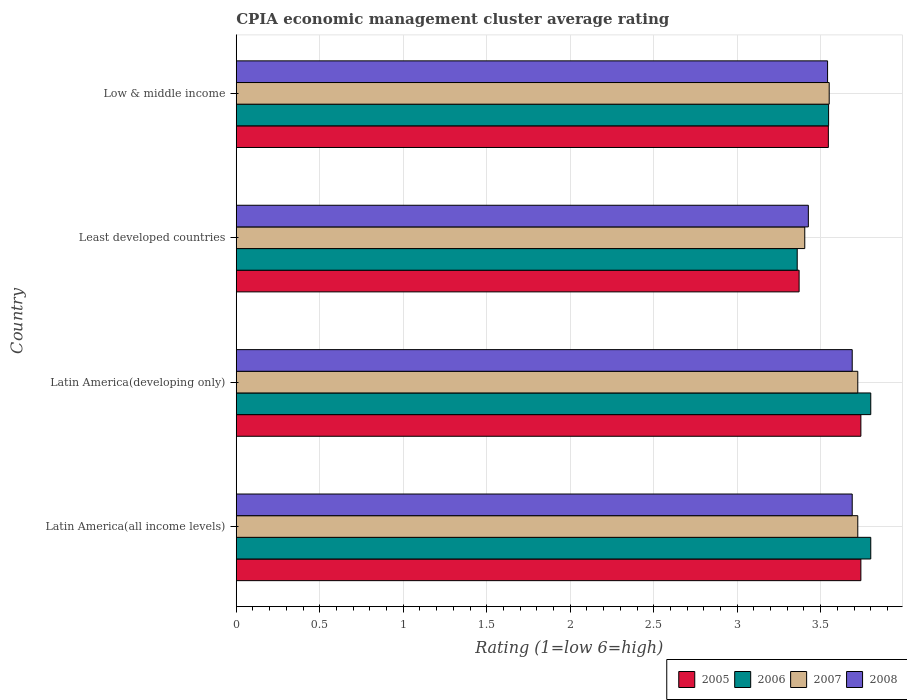How many different coloured bars are there?
Keep it short and to the point. 4. Are the number of bars per tick equal to the number of legend labels?
Offer a very short reply. Yes. What is the CPIA rating in 2008 in Latin America(all income levels)?
Ensure brevity in your answer.  3.69. Across all countries, what is the maximum CPIA rating in 2006?
Offer a very short reply. 3.8. Across all countries, what is the minimum CPIA rating in 2007?
Offer a very short reply. 3.4. In which country was the CPIA rating in 2007 maximum?
Your answer should be very brief. Latin America(all income levels). In which country was the CPIA rating in 2005 minimum?
Ensure brevity in your answer.  Least developed countries. What is the total CPIA rating in 2006 in the graph?
Make the answer very short. 14.51. What is the difference between the CPIA rating in 2008 in Latin America(developing only) and that in Least developed countries?
Your response must be concise. 0.26. What is the difference between the CPIA rating in 2006 in Latin America(all income levels) and the CPIA rating in 2005 in Least developed countries?
Make the answer very short. 0.43. What is the average CPIA rating in 2007 per country?
Ensure brevity in your answer.  3.6. What is the difference between the CPIA rating in 2005 and CPIA rating in 2007 in Latin America(developing only)?
Provide a short and direct response. 0.02. In how many countries, is the CPIA rating in 2006 greater than 0.8 ?
Give a very brief answer. 4. What is the ratio of the CPIA rating in 2007 in Least developed countries to that in Low & middle income?
Your answer should be very brief. 0.96. Is the CPIA rating in 2005 in Latin America(developing only) less than that in Low & middle income?
Your response must be concise. No. Is the difference between the CPIA rating in 2005 in Latin America(all income levels) and Latin America(developing only) greater than the difference between the CPIA rating in 2007 in Latin America(all income levels) and Latin America(developing only)?
Give a very brief answer. No. What is the difference between the highest and the second highest CPIA rating in 2005?
Make the answer very short. 0. What is the difference between the highest and the lowest CPIA rating in 2007?
Offer a very short reply. 0.32. Is it the case that in every country, the sum of the CPIA rating in 2008 and CPIA rating in 2006 is greater than the sum of CPIA rating in 2007 and CPIA rating in 2005?
Give a very brief answer. No. What does the 2nd bar from the top in Latin America(all income levels) represents?
Your response must be concise. 2007. Are all the bars in the graph horizontal?
Offer a terse response. Yes. Does the graph contain any zero values?
Give a very brief answer. No. Does the graph contain grids?
Provide a succinct answer. Yes. How many legend labels are there?
Offer a terse response. 4. How are the legend labels stacked?
Offer a very short reply. Horizontal. What is the title of the graph?
Ensure brevity in your answer.  CPIA economic management cluster average rating. What is the label or title of the X-axis?
Keep it short and to the point. Rating (1=low 6=high). What is the label or title of the Y-axis?
Keep it short and to the point. Country. What is the Rating (1=low 6=high) of 2005 in Latin America(all income levels)?
Provide a short and direct response. 3.74. What is the Rating (1=low 6=high) of 2006 in Latin America(all income levels)?
Give a very brief answer. 3.8. What is the Rating (1=low 6=high) of 2007 in Latin America(all income levels)?
Offer a very short reply. 3.72. What is the Rating (1=low 6=high) of 2008 in Latin America(all income levels)?
Offer a terse response. 3.69. What is the Rating (1=low 6=high) in 2005 in Latin America(developing only)?
Your answer should be compact. 3.74. What is the Rating (1=low 6=high) in 2007 in Latin America(developing only)?
Your answer should be compact. 3.72. What is the Rating (1=low 6=high) of 2008 in Latin America(developing only)?
Give a very brief answer. 3.69. What is the Rating (1=low 6=high) of 2005 in Least developed countries?
Give a very brief answer. 3.37. What is the Rating (1=low 6=high) in 2006 in Least developed countries?
Your answer should be very brief. 3.36. What is the Rating (1=low 6=high) in 2007 in Least developed countries?
Your answer should be compact. 3.4. What is the Rating (1=low 6=high) in 2008 in Least developed countries?
Provide a succinct answer. 3.43. What is the Rating (1=low 6=high) in 2005 in Low & middle income?
Your answer should be very brief. 3.55. What is the Rating (1=low 6=high) in 2006 in Low & middle income?
Offer a very short reply. 3.55. What is the Rating (1=low 6=high) of 2007 in Low & middle income?
Your answer should be compact. 3.55. What is the Rating (1=low 6=high) in 2008 in Low & middle income?
Your answer should be compact. 3.54. Across all countries, what is the maximum Rating (1=low 6=high) in 2005?
Make the answer very short. 3.74. Across all countries, what is the maximum Rating (1=low 6=high) in 2006?
Your answer should be very brief. 3.8. Across all countries, what is the maximum Rating (1=low 6=high) of 2007?
Your answer should be very brief. 3.72. Across all countries, what is the maximum Rating (1=low 6=high) of 2008?
Your response must be concise. 3.69. Across all countries, what is the minimum Rating (1=low 6=high) in 2005?
Your answer should be compact. 3.37. Across all countries, what is the minimum Rating (1=low 6=high) of 2006?
Make the answer very short. 3.36. Across all countries, what is the minimum Rating (1=low 6=high) in 2007?
Your answer should be compact. 3.4. Across all countries, what is the minimum Rating (1=low 6=high) of 2008?
Give a very brief answer. 3.43. What is the total Rating (1=low 6=high) of 2005 in the graph?
Ensure brevity in your answer.  14.4. What is the total Rating (1=low 6=high) in 2006 in the graph?
Ensure brevity in your answer.  14.51. What is the total Rating (1=low 6=high) of 2007 in the graph?
Your response must be concise. 14.4. What is the total Rating (1=low 6=high) of 2008 in the graph?
Your answer should be compact. 14.35. What is the difference between the Rating (1=low 6=high) in 2006 in Latin America(all income levels) and that in Latin America(developing only)?
Your response must be concise. 0. What is the difference between the Rating (1=low 6=high) of 2005 in Latin America(all income levels) and that in Least developed countries?
Ensure brevity in your answer.  0.37. What is the difference between the Rating (1=low 6=high) in 2006 in Latin America(all income levels) and that in Least developed countries?
Provide a short and direct response. 0.44. What is the difference between the Rating (1=low 6=high) of 2007 in Latin America(all income levels) and that in Least developed countries?
Your answer should be compact. 0.32. What is the difference between the Rating (1=low 6=high) of 2008 in Latin America(all income levels) and that in Least developed countries?
Make the answer very short. 0.26. What is the difference between the Rating (1=low 6=high) of 2005 in Latin America(all income levels) and that in Low & middle income?
Provide a succinct answer. 0.19. What is the difference between the Rating (1=low 6=high) in 2006 in Latin America(all income levels) and that in Low & middle income?
Give a very brief answer. 0.25. What is the difference between the Rating (1=low 6=high) of 2007 in Latin America(all income levels) and that in Low & middle income?
Ensure brevity in your answer.  0.17. What is the difference between the Rating (1=low 6=high) in 2008 in Latin America(all income levels) and that in Low & middle income?
Provide a short and direct response. 0.15. What is the difference between the Rating (1=low 6=high) of 2005 in Latin America(developing only) and that in Least developed countries?
Offer a very short reply. 0.37. What is the difference between the Rating (1=low 6=high) in 2006 in Latin America(developing only) and that in Least developed countries?
Make the answer very short. 0.44. What is the difference between the Rating (1=low 6=high) in 2007 in Latin America(developing only) and that in Least developed countries?
Offer a terse response. 0.32. What is the difference between the Rating (1=low 6=high) in 2008 in Latin America(developing only) and that in Least developed countries?
Your response must be concise. 0.26. What is the difference between the Rating (1=low 6=high) of 2005 in Latin America(developing only) and that in Low & middle income?
Offer a terse response. 0.19. What is the difference between the Rating (1=low 6=high) in 2006 in Latin America(developing only) and that in Low & middle income?
Ensure brevity in your answer.  0.25. What is the difference between the Rating (1=low 6=high) of 2007 in Latin America(developing only) and that in Low & middle income?
Your answer should be compact. 0.17. What is the difference between the Rating (1=low 6=high) of 2008 in Latin America(developing only) and that in Low & middle income?
Your answer should be compact. 0.15. What is the difference between the Rating (1=low 6=high) of 2005 in Least developed countries and that in Low & middle income?
Offer a terse response. -0.18. What is the difference between the Rating (1=low 6=high) in 2006 in Least developed countries and that in Low & middle income?
Offer a terse response. -0.19. What is the difference between the Rating (1=low 6=high) in 2007 in Least developed countries and that in Low & middle income?
Your answer should be compact. -0.15. What is the difference between the Rating (1=low 6=high) in 2008 in Least developed countries and that in Low & middle income?
Offer a very short reply. -0.12. What is the difference between the Rating (1=low 6=high) in 2005 in Latin America(all income levels) and the Rating (1=low 6=high) in 2006 in Latin America(developing only)?
Your answer should be very brief. -0.06. What is the difference between the Rating (1=low 6=high) of 2005 in Latin America(all income levels) and the Rating (1=low 6=high) of 2007 in Latin America(developing only)?
Make the answer very short. 0.02. What is the difference between the Rating (1=low 6=high) in 2005 in Latin America(all income levels) and the Rating (1=low 6=high) in 2008 in Latin America(developing only)?
Offer a terse response. 0.05. What is the difference between the Rating (1=low 6=high) in 2006 in Latin America(all income levels) and the Rating (1=low 6=high) in 2007 in Latin America(developing only)?
Your response must be concise. 0.08. What is the difference between the Rating (1=low 6=high) of 2006 in Latin America(all income levels) and the Rating (1=low 6=high) of 2008 in Latin America(developing only)?
Keep it short and to the point. 0.11. What is the difference between the Rating (1=low 6=high) in 2007 in Latin America(all income levels) and the Rating (1=low 6=high) in 2008 in Latin America(developing only)?
Your answer should be compact. 0.03. What is the difference between the Rating (1=low 6=high) of 2005 in Latin America(all income levels) and the Rating (1=low 6=high) of 2006 in Least developed countries?
Provide a short and direct response. 0.38. What is the difference between the Rating (1=low 6=high) in 2005 in Latin America(all income levels) and the Rating (1=low 6=high) in 2007 in Least developed countries?
Your response must be concise. 0.34. What is the difference between the Rating (1=low 6=high) in 2005 in Latin America(all income levels) and the Rating (1=low 6=high) in 2008 in Least developed countries?
Your answer should be very brief. 0.31. What is the difference between the Rating (1=low 6=high) in 2006 in Latin America(all income levels) and the Rating (1=low 6=high) in 2007 in Least developed countries?
Provide a short and direct response. 0.4. What is the difference between the Rating (1=low 6=high) in 2006 in Latin America(all income levels) and the Rating (1=low 6=high) in 2008 in Least developed countries?
Make the answer very short. 0.37. What is the difference between the Rating (1=low 6=high) of 2007 in Latin America(all income levels) and the Rating (1=low 6=high) of 2008 in Least developed countries?
Offer a very short reply. 0.3. What is the difference between the Rating (1=low 6=high) of 2005 in Latin America(all income levels) and the Rating (1=low 6=high) of 2006 in Low & middle income?
Ensure brevity in your answer.  0.19. What is the difference between the Rating (1=low 6=high) of 2005 in Latin America(all income levels) and the Rating (1=low 6=high) of 2007 in Low & middle income?
Provide a succinct answer. 0.19. What is the difference between the Rating (1=low 6=high) of 2005 in Latin America(all income levels) and the Rating (1=low 6=high) of 2008 in Low & middle income?
Keep it short and to the point. 0.2. What is the difference between the Rating (1=low 6=high) in 2006 in Latin America(all income levels) and the Rating (1=low 6=high) in 2007 in Low & middle income?
Your answer should be very brief. 0.25. What is the difference between the Rating (1=low 6=high) of 2006 in Latin America(all income levels) and the Rating (1=low 6=high) of 2008 in Low & middle income?
Make the answer very short. 0.26. What is the difference between the Rating (1=low 6=high) of 2007 in Latin America(all income levels) and the Rating (1=low 6=high) of 2008 in Low & middle income?
Your response must be concise. 0.18. What is the difference between the Rating (1=low 6=high) of 2005 in Latin America(developing only) and the Rating (1=low 6=high) of 2006 in Least developed countries?
Your response must be concise. 0.38. What is the difference between the Rating (1=low 6=high) in 2005 in Latin America(developing only) and the Rating (1=low 6=high) in 2007 in Least developed countries?
Provide a succinct answer. 0.34. What is the difference between the Rating (1=low 6=high) in 2005 in Latin America(developing only) and the Rating (1=low 6=high) in 2008 in Least developed countries?
Make the answer very short. 0.31. What is the difference between the Rating (1=low 6=high) of 2006 in Latin America(developing only) and the Rating (1=low 6=high) of 2007 in Least developed countries?
Your answer should be very brief. 0.4. What is the difference between the Rating (1=low 6=high) of 2006 in Latin America(developing only) and the Rating (1=low 6=high) of 2008 in Least developed countries?
Your response must be concise. 0.37. What is the difference between the Rating (1=low 6=high) in 2007 in Latin America(developing only) and the Rating (1=low 6=high) in 2008 in Least developed countries?
Keep it short and to the point. 0.3. What is the difference between the Rating (1=low 6=high) in 2005 in Latin America(developing only) and the Rating (1=low 6=high) in 2006 in Low & middle income?
Give a very brief answer. 0.19. What is the difference between the Rating (1=low 6=high) in 2005 in Latin America(developing only) and the Rating (1=low 6=high) in 2007 in Low & middle income?
Make the answer very short. 0.19. What is the difference between the Rating (1=low 6=high) in 2005 in Latin America(developing only) and the Rating (1=low 6=high) in 2008 in Low & middle income?
Your answer should be very brief. 0.2. What is the difference between the Rating (1=low 6=high) in 2006 in Latin America(developing only) and the Rating (1=low 6=high) in 2007 in Low & middle income?
Your response must be concise. 0.25. What is the difference between the Rating (1=low 6=high) in 2006 in Latin America(developing only) and the Rating (1=low 6=high) in 2008 in Low & middle income?
Keep it short and to the point. 0.26. What is the difference between the Rating (1=low 6=high) in 2007 in Latin America(developing only) and the Rating (1=low 6=high) in 2008 in Low & middle income?
Your answer should be very brief. 0.18. What is the difference between the Rating (1=low 6=high) in 2005 in Least developed countries and the Rating (1=low 6=high) in 2006 in Low & middle income?
Offer a terse response. -0.18. What is the difference between the Rating (1=low 6=high) in 2005 in Least developed countries and the Rating (1=low 6=high) in 2007 in Low & middle income?
Keep it short and to the point. -0.18. What is the difference between the Rating (1=low 6=high) of 2005 in Least developed countries and the Rating (1=low 6=high) of 2008 in Low & middle income?
Make the answer very short. -0.17. What is the difference between the Rating (1=low 6=high) of 2006 in Least developed countries and the Rating (1=low 6=high) of 2007 in Low & middle income?
Ensure brevity in your answer.  -0.19. What is the difference between the Rating (1=low 6=high) of 2006 in Least developed countries and the Rating (1=low 6=high) of 2008 in Low & middle income?
Make the answer very short. -0.18. What is the difference between the Rating (1=low 6=high) in 2007 in Least developed countries and the Rating (1=low 6=high) in 2008 in Low & middle income?
Keep it short and to the point. -0.14. What is the average Rating (1=low 6=high) in 2005 per country?
Your answer should be compact. 3.6. What is the average Rating (1=low 6=high) in 2006 per country?
Offer a terse response. 3.63. What is the average Rating (1=low 6=high) of 2007 per country?
Offer a very short reply. 3.6. What is the average Rating (1=low 6=high) of 2008 per country?
Make the answer very short. 3.59. What is the difference between the Rating (1=low 6=high) in 2005 and Rating (1=low 6=high) in 2006 in Latin America(all income levels)?
Your answer should be compact. -0.06. What is the difference between the Rating (1=low 6=high) in 2005 and Rating (1=low 6=high) in 2007 in Latin America(all income levels)?
Make the answer very short. 0.02. What is the difference between the Rating (1=low 6=high) of 2005 and Rating (1=low 6=high) of 2008 in Latin America(all income levels)?
Make the answer very short. 0.05. What is the difference between the Rating (1=low 6=high) in 2006 and Rating (1=low 6=high) in 2007 in Latin America(all income levels)?
Ensure brevity in your answer.  0.08. What is the difference between the Rating (1=low 6=high) in 2006 and Rating (1=low 6=high) in 2008 in Latin America(all income levels)?
Give a very brief answer. 0.11. What is the difference between the Rating (1=low 6=high) in 2005 and Rating (1=low 6=high) in 2006 in Latin America(developing only)?
Ensure brevity in your answer.  -0.06. What is the difference between the Rating (1=low 6=high) of 2005 and Rating (1=low 6=high) of 2007 in Latin America(developing only)?
Make the answer very short. 0.02. What is the difference between the Rating (1=low 6=high) in 2005 and Rating (1=low 6=high) in 2008 in Latin America(developing only)?
Give a very brief answer. 0.05. What is the difference between the Rating (1=low 6=high) of 2006 and Rating (1=low 6=high) of 2007 in Latin America(developing only)?
Your answer should be compact. 0.08. What is the difference between the Rating (1=low 6=high) of 2007 and Rating (1=low 6=high) of 2008 in Latin America(developing only)?
Offer a very short reply. 0.03. What is the difference between the Rating (1=low 6=high) in 2005 and Rating (1=low 6=high) in 2006 in Least developed countries?
Your response must be concise. 0.01. What is the difference between the Rating (1=low 6=high) of 2005 and Rating (1=low 6=high) of 2007 in Least developed countries?
Make the answer very short. -0.03. What is the difference between the Rating (1=low 6=high) in 2005 and Rating (1=low 6=high) in 2008 in Least developed countries?
Provide a short and direct response. -0.06. What is the difference between the Rating (1=low 6=high) of 2006 and Rating (1=low 6=high) of 2007 in Least developed countries?
Provide a short and direct response. -0.05. What is the difference between the Rating (1=low 6=high) of 2006 and Rating (1=low 6=high) of 2008 in Least developed countries?
Keep it short and to the point. -0.07. What is the difference between the Rating (1=low 6=high) of 2007 and Rating (1=low 6=high) of 2008 in Least developed countries?
Give a very brief answer. -0.02. What is the difference between the Rating (1=low 6=high) in 2005 and Rating (1=low 6=high) in 2006 in Low & middle income?
Make the answer very short. -0. What is the difference between the Rating (1=low 6=high) in 2005 and Rating (1=low 6=high) in 2007 in Low & middle income?
Offer a terse response. -0.01. What is the difference between the Rating (1=low 6=high) in 2005 and Rating (1=low 6=high) in 2008 in Low & middle income?
Make the answer very short. 0. What is the difference between the Rating (1=low 6=high) in 2006 and Rating (1=low 6=high) in 2007 in Low & middle income?
Give a very brief answer. -0. What is the difference between the Rating (1=low 6=high) of 2006 and Rating (1=low 6=high) of 2008 in Low & middle income?
Your answer should be very brief. 0.01. What is the difference between the Rating (1=low 6=high) of 2007 and Rating (1=low 6=high) of 2008 in Low & middle income?
Your response must be concise. 0.01. What is the ratio of the Rating (1=low 6=high) of 2005 in Latin America(all income levels) to that in Latin America(developing only)?
Make the answer very short. 1. What is the ratio of the Rating (1=low 6=high) of 2007 in Latin America(all income levels) to that in Latin America(developing only)?
Keep it short and to the point. 1. What is the ratio of the Rating (1=low 6=high) of 2005 in Latin America(all income levels) to that in Least developed countries?
Your response must be concise. 1.11. What is the ratio of the Rating (1=low 6=high) of 2006 in Latin America(all income levels) to that in Least developed countries?
Keep it short and to the point. 1.13. What is the ratio of the Rating (1=low 6=high) in 2007 in Latin America(all income levels) to that in Least developed countries?
Your answer should be compact. 1.09. What is the ratio of the Rating (1=low 6=high) of 2008 in Latin America(all income levels) to that in Least developed countries?
Ensure brevity in your answer.  1.08. What is the ratio of the Rating (1=low 6=high) in 2005 in Latin America(all income levels) to that in Low & middle income?
Give a very brief answer. 1.05. What is the ratio of the Rating (1=low 6=high) of 2006 in Latin America(all income levels) to that in Low & middle income?
Provide a succinct answer. 1.07. What is the ratio of the Rating (1=low 6=high) of 2007 in Latin America(all income levels) to that in Low & middle income?
Provide a short and direct response. 1.05. What is the ratio of the Rating (1=low 6=high) of 2008 in Latin America(all income levels) to that in Low & middle income?
Provide a succinct answer. 1.04. What is the ratio of the Rating (1=low 6=high) in 2005 in Latin America(developing only) to that in Least developed countries?
Make the answer very short. 1.11. What is the ratio of the Rating (1=low 6=high) of 2006 in Latin America(developing only) to that in Least developed countries?
Provide a short and direct response. 1.13. What is the ratio of the Rating (1=low 6=high) in 2007 in Latin America(developing only) to that in Least developed countries?
Provide a short and direct response. 1.09. What is the ratio of the Rating (1=low 6=high) in 2008 in Latin America(developing only) to that in Least developed countries?
Offer a very short reply. 1.08. What is the ratio of the Rating (1=low 6=high) of 2005 in Latin America(developing only) to that in Low & middle income?
Your answer should be very brief. 1.05. What is the ratio of the Rating (1=low 6=high) of 2006 in Latin America(developing only) to that in Low & middle income?
Provide a short and direct response. 1.07. What is the ratio of the Rating (1=low 6=high) of 2007 in Latin America(developing only) to that in Low & middle income?
Make the answer very short. 1.05. What is the ratio of the Rating (1=low 6=high) in 2008 in Latin America(developing only) to that in Low & middle income?
Your answer should be compact. 1.04. What is the ratio of the Rating (1=low 6=high) of 2005 in Least developed countries to that in Low & middle income?
Make the answer very short. 0.95. What is the ratio of the Rating (1=low 6=high) of 2006 in Least developed countries to that in Low & middle income?
Provide a short and direct response. 0.95. What is the ratio of the Rating (1=low 6=high) in 2007 in Least developed countries to that in Low & middle income?
Your response must be concise. 0.96. What is the ratio of the Rating (1=low 6=high) of 2008 in Least developed countries to that in Low & middle income?
Ensure brevity in your answer.  0.97. What is the difference between the highest and the second highest Rating (1=low 6=high) in 2005?
Make the answer very short. 0. What is the difference between the highest and the second highest Rating (1=low 6=high) of 2006?
Your answer should be very brief. 0. What is the difference between the highest and the lowest Rating (1=low 6=high) of 2005?
Ensure brevity in your answer.  0.37. What is the difference between the highest and the lowest Rating (1=low 6=high) in 2006?
Offer a terse response. 0.44. What is the difference between the highest and the lowest Rating (1=low 6=high) in 2007?
Your answer should be very brief. 0.32. What is the difference between the highest and the lowest Rating (1=low 6=high) in 2008?
Give a very brief answer. 0.26. 